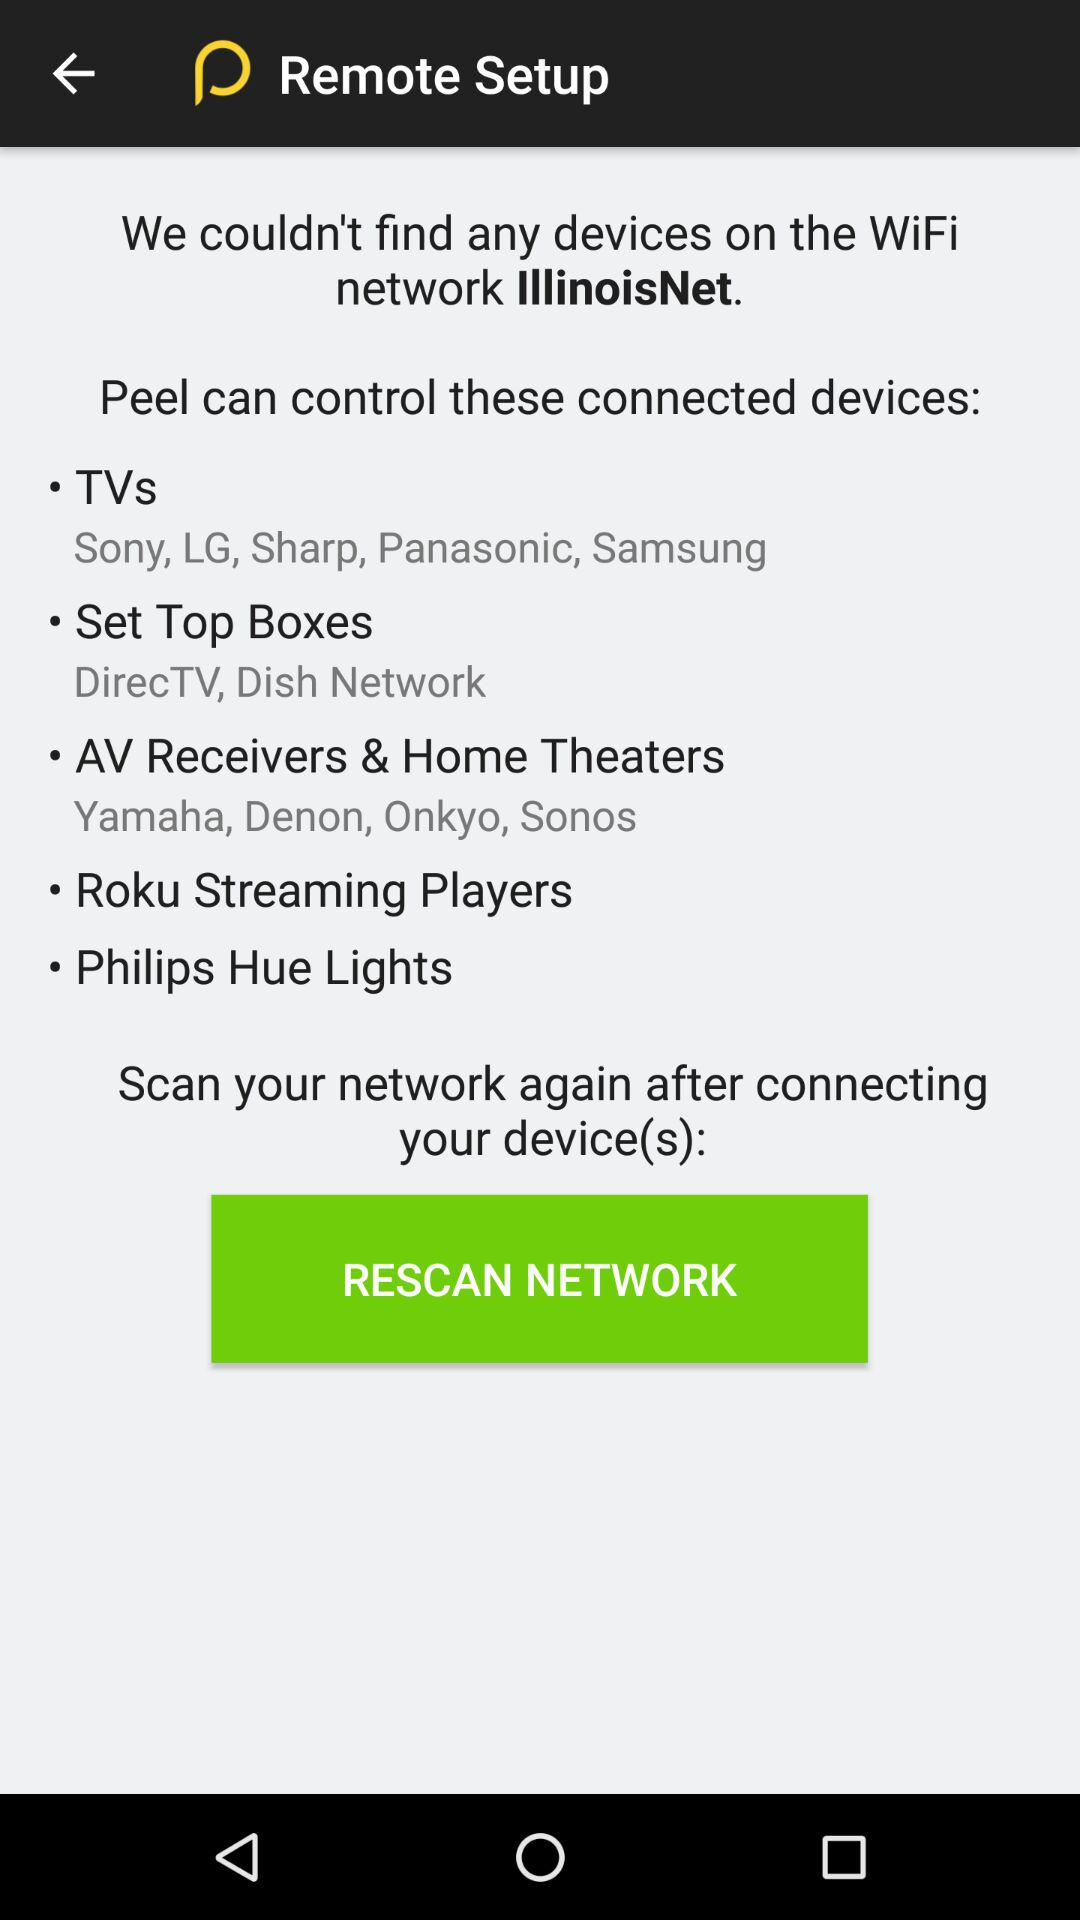Which WiFi network is connected?
When the provided information is insufficient, respond with <no answer>. <no answer> 